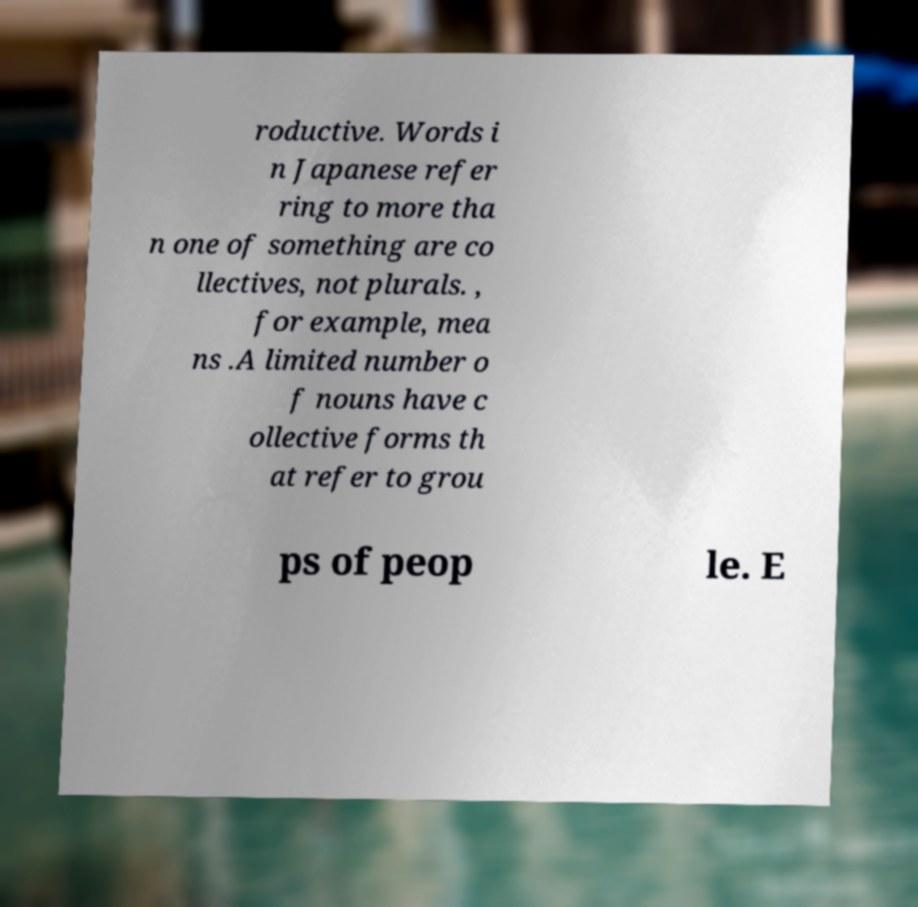Can you read and provide the text displayed in the image?This photo seems to have some interesting text. Can you extract and type it out for me? roductive. Words i n Japanese refer ring to more tha n one of something are co llectives, not plurals. , for example, mea ns .A limited number o f nouns have c ollective forms th at refer to grou ps of peop le. E 